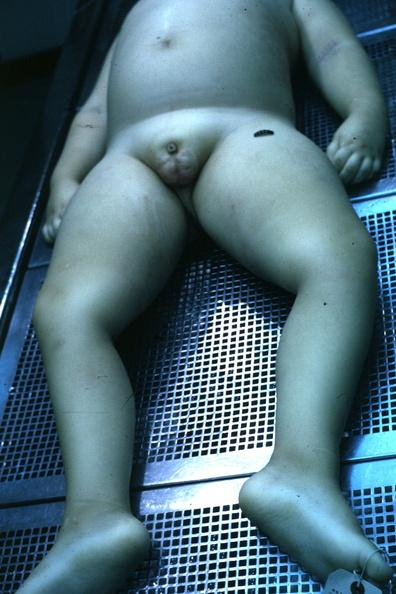how does this image show view of body?
Answer the question using a single word or phrase. With small penis and rather flat scrotal sac case 7yo with craniopharyngioma 